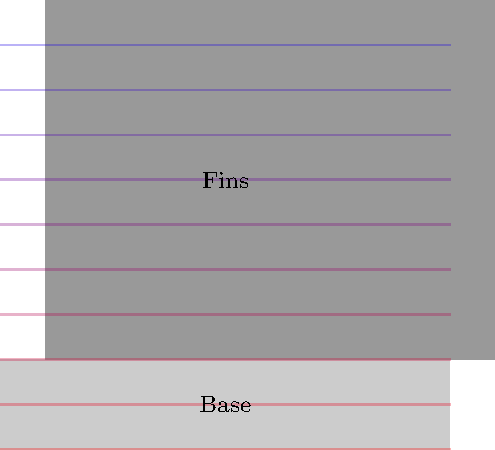In a heat sink with multiple fins, as shown in the diagram, how does the temperature distribution typically vary from the base to the tip of the fins? Consider this in the context of composing a soundtrack that captures the essence of heat transfer, similar to how Renaissance composers used musical motifs to represent natural phenomena. To understand the temperature distribution in a heat sink with multiple fins, let's break it down step-by-step:

1. Heat Source: The base of the heat sink is in contact with the heat source (e.g., a computer processor). This is where the temperature is highest.

2. Conduction: Heat is conducted from the base through the fins. The thermal conductivity of the material (usually aluminum or copper) allows heat to flow along the fins.

3. Temperature Gradient: As heat moves away from the source, the temperature gradually decreases. This creates a temperature gradient along the length of each fin.

4. Fin Efficiency: The effectiveness of heat transfer depends on the fin's thermal conductivity, geometry, and ambient conditions. Longer fins may have a more pronounced temperature gradient.

5. Convection: As air moves over the fins (either naturally or forced), it carries heat away. This convective heat transfer is more effective at the fin tips and outer surfaces.

6. Tip Temperature: The tips of the fins are furthest from the heat source and have the most exposure to the cooling air, resulting in the lowest temperatures.

7. Non-linear Distribution: The temperature distribution is typically non-linear, with a steeper gradient near the base and a more gradual change towards the tips.

In musical terms, this temperature distribution could be represented by a descending melody line, where the pitch gradually lowers from the base to the tip, much like how Renaissance composers might have used descending scales to represent flowing water or falling objects.
Answer: Temperature decreases non-linearly from base to fin tips. 